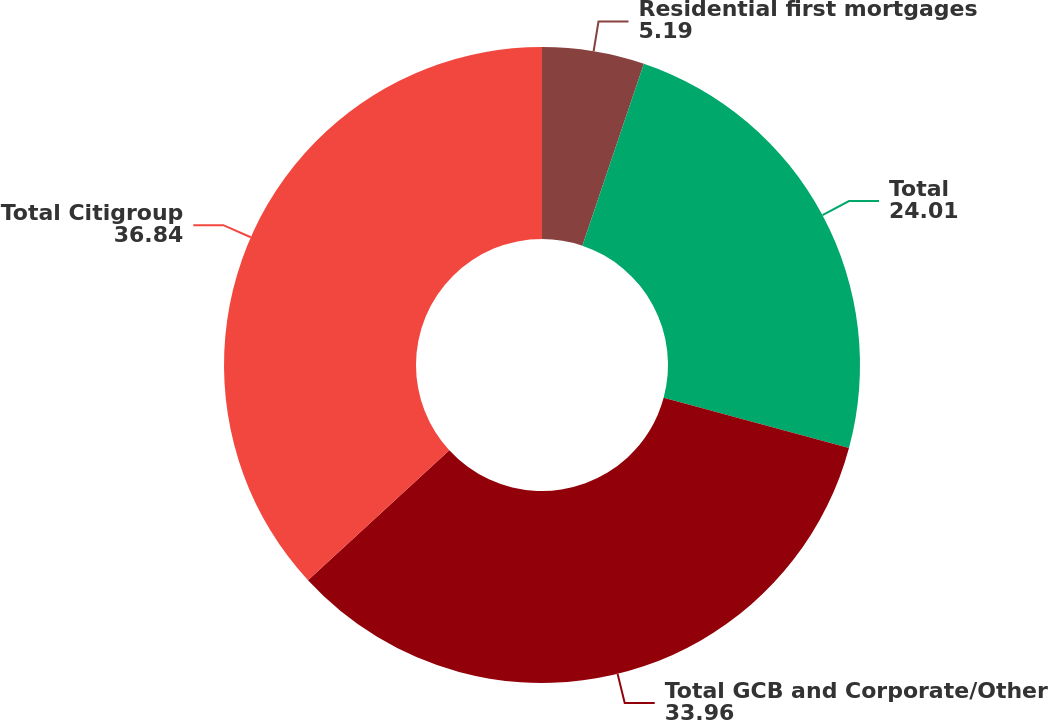<chart> <loc_0><loc_0><loc_500><loc_500><pie_chart><fcel>Residential first mortgages<fcel>Total<fcel>Total GCB and Corporate/Other<fcel>Total Citigroup<nl><fcel>5.19%<fcel>24.01%<fcel>33.96%<fcel>36.84%<nl></chart> 